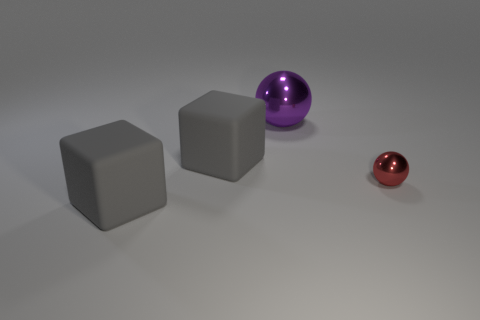Add 3 big metallic objects. How many objects exist? 7 Add 1 big purple shiny balls. How many big purple shiny balls exist? 2 Subtract 0 green spheres. How many objects are left? 4 Subtract all tiny yellow things. Subtract all big purple objects. How many objects are left? 3 Add 3 tiny red shiny spheres. How many tiny red shiny spheres are left? 4 